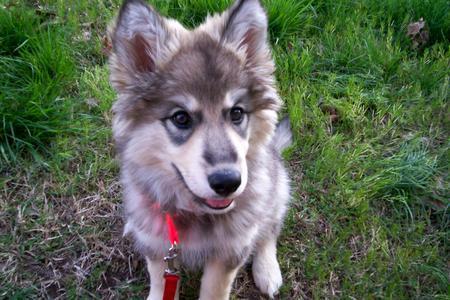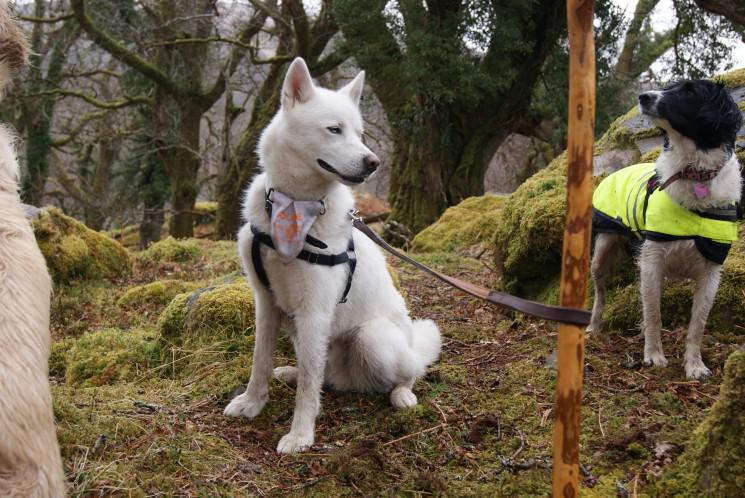The first image is the image on the left, the second image is the image on the right. Assess this claim about the two images: "The left and right image contains the same number of dogs.". Correct or not? Answer yes or no. No. The first image is the image on the left, the second image is the image on the right. Analyze the images presented: Is the assertion "A dog is standing in the grass." valid? Answer yes or no. No. 